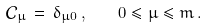Convert formula to latex. <formula><loc_0><loc_0><loc_500><loc_500>\mathcal { C } _ { \mu } \, = \, \delta _ { \mu 0 } \, , \quad 0 \leq \mu \leq m \, .</formula> 